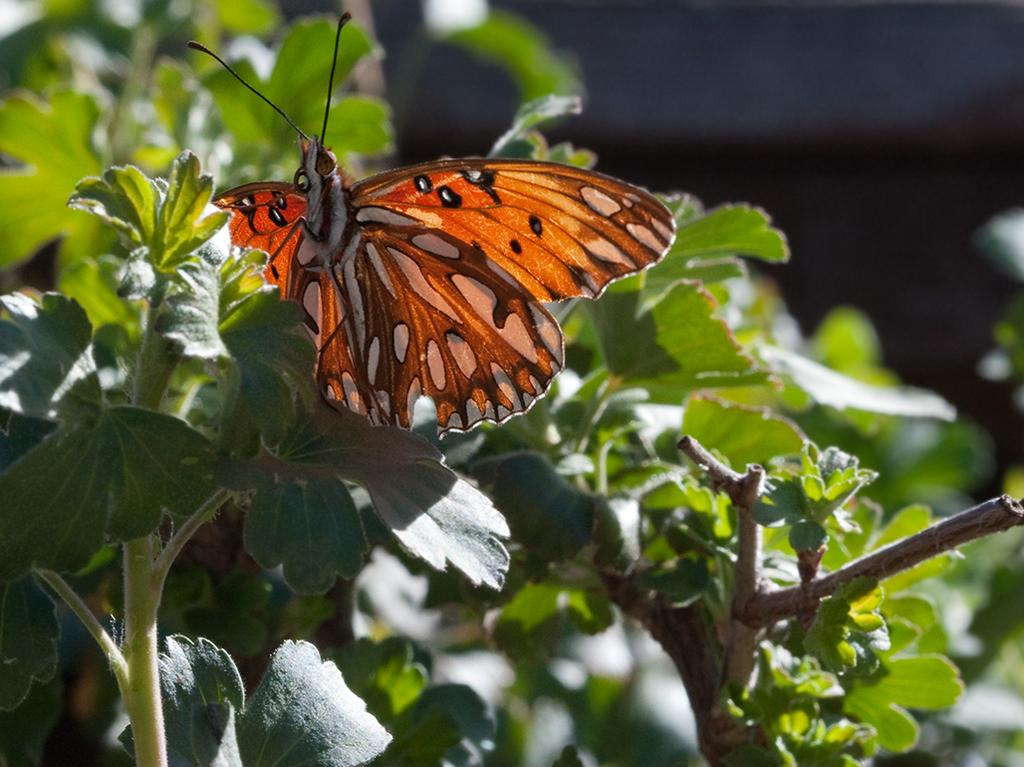What type of animal can be seen in the image? There is a butterfly on a plant in the image. What can be seen in the background of the image? There are green leaves in the background of the image. What else is visible in the background of the image? There are stems visible in the background of the image. What type of watch is the butterfly wearing in the image? There is no watch present in the image, as butterflies do not wear watches. How many jewels can be seen on the butterfly in the image? There are no jewels present in the image, as butterflies do not wear or possess jewels. 